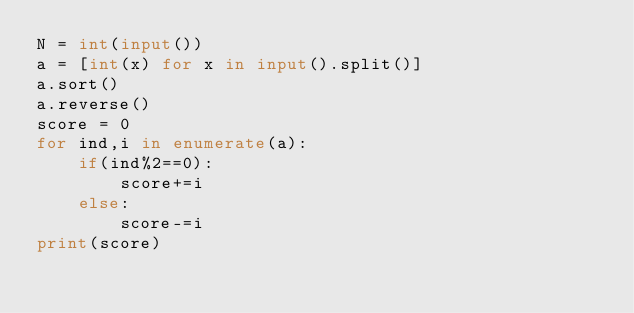Convert code to text. <code><loc_0><loc_0><loc_500><loc_500><_Python_>N = int(input())
a = [int(x) for x in input().split()]
a.sort()
a.reverse()
score = 0
for ind,i in enumerate(a):
    if(ind%2==0):
        score+=i
    else:
        score-=i
print(score)
</code> 